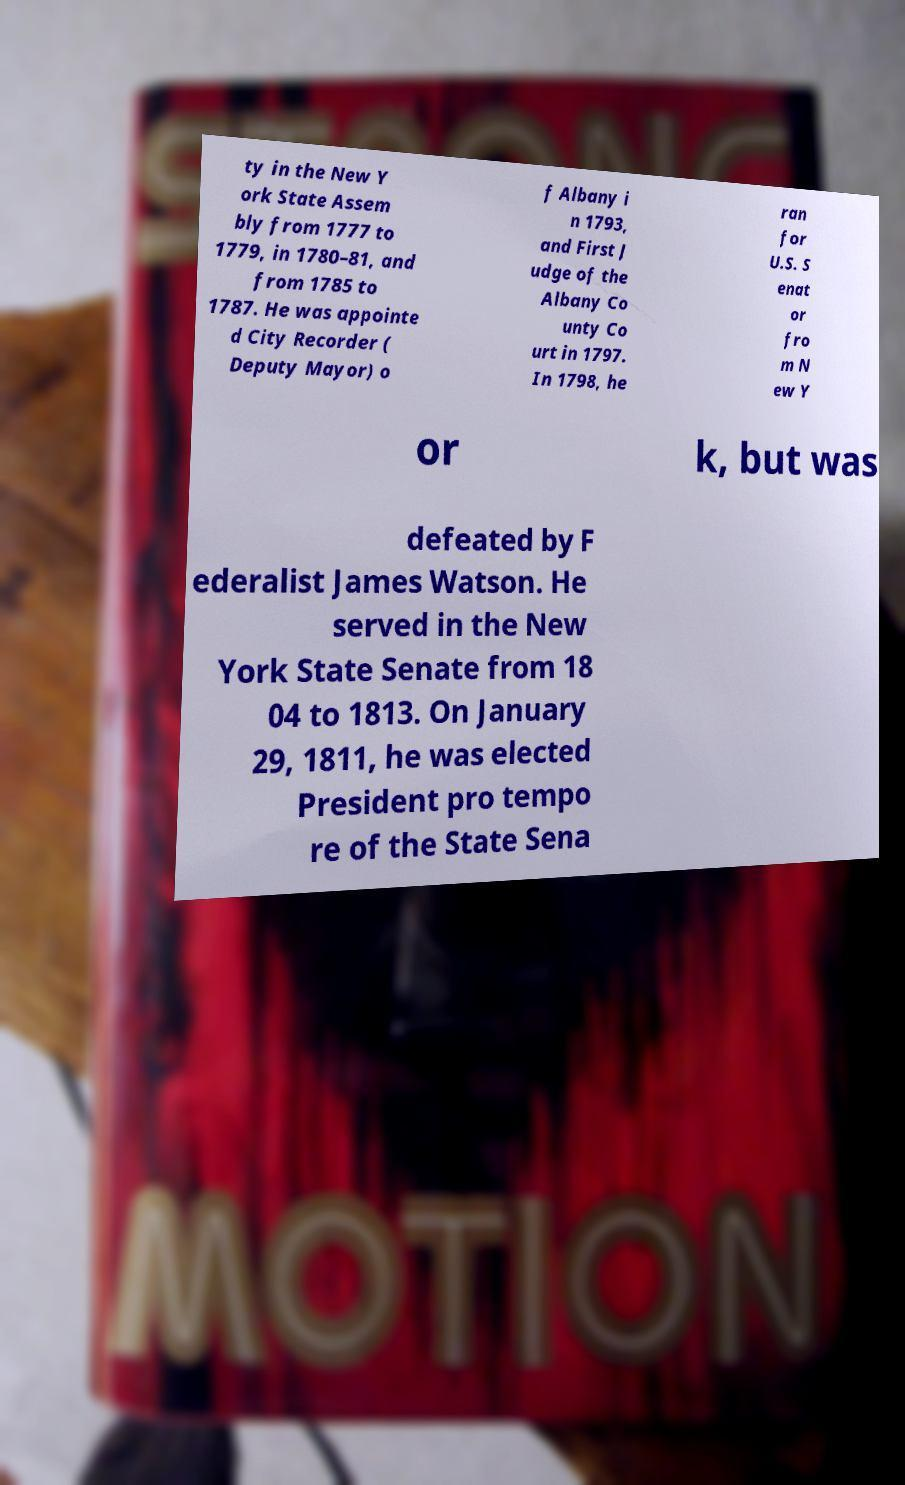What messages or text are displayed in this image? I need them in a readable, typed format. ty in the New Y ork State Assem bly from 1777 to 1779, in 1780–81, and from 1785 to 1787. He was appointe d City Recorder ( Deputy Mayor) o f Albany i n 1793, and First J udge of the Albany Co unty Co urt in 1797. In 1798, he ran for U.S. S enat or fro m N ew Y or k, but was defeated by F ederalist James Watson. He served in the New York State Senate from 18 04 to 1813. On January 29, 1811, he was elected President pro tempo re of the State Sena 